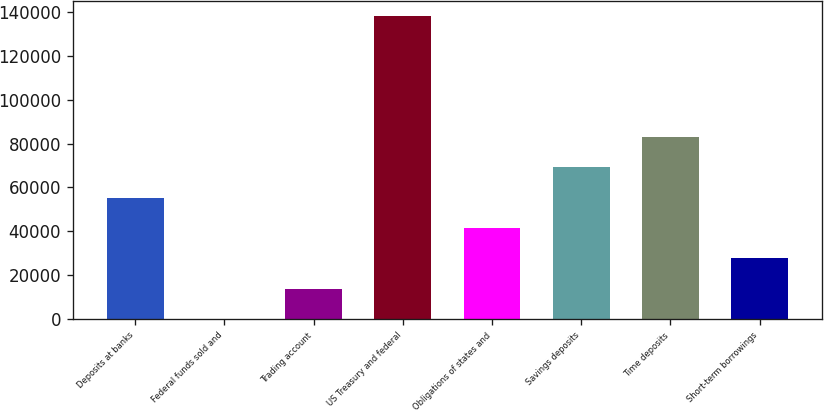<chart> <loc_0><loc_0><loc_500><loc_500><bar_chart><fcel>Deposits at banks<fcel>Federal funds sold and<fcel>Trading account<fcel>US Treasury and federal<fcel>Obligations of states and<fcel>Savings deposits<fcel>Time deposits<fcel>Short-term borrowings<nl><fcel>55349.6<fcel>50<fcel>13874.9<fcel>138299<fcel>41524.7<fcel>69174.5<fcel>82999.4<fcel>27699.8<nl></chart> 